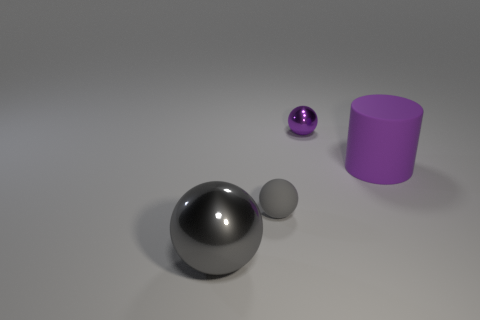There is a shiny thing on the left side of the purple shiny thing; how many big gray spheres are to the left of it?
Your response must be concise. 0. There is a tiny gray object that is the same shape as the tiny purple object; what is its material?
Provide a succinct answer. Rubber. There is a big cylinder right of the big gray sphere; is it the same color as the tiny metallic object?
Provide a short and direct response. Yes. Is the material of the large gray object the same as the sphere on the right side of the gray matte ball?
Give a very brief answer. Yes. There is a large thing on the right side of the tiny purple metallic ball; what shape is it?
Your answer should be compact. Cylinder. How many other things are there of the same material as the tiny purple sphere?
Keep it short and to the point. 1. The purple shiny ball is what size?
Your response must be concise. Small. How many other things are there of the same color as the small metallic thing?
Offer a very short reply. 1. There is a object that is right of the gray rubber thing and to the left of the cylinder; what is its color?
Offer a very short reply. Purple. What number of blocks are there?
Give a very brief answer. 0. 